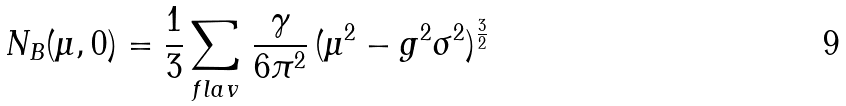Convert formula to latex. <formula><loc_0><loc_0><loc_500><loc_500>N _ { B } ( \mu , 0 ) = \frac { 1 } { 3 } \sum _ { f l a v } \, \frac { \gamma } { 6 \pi ^ { 2 } } \, ( \mu ^ { 2 } - g ^ { 2 } \sigma ^ { 2 } ) ^ { \frac { 3 } { 2 } }</formula> 